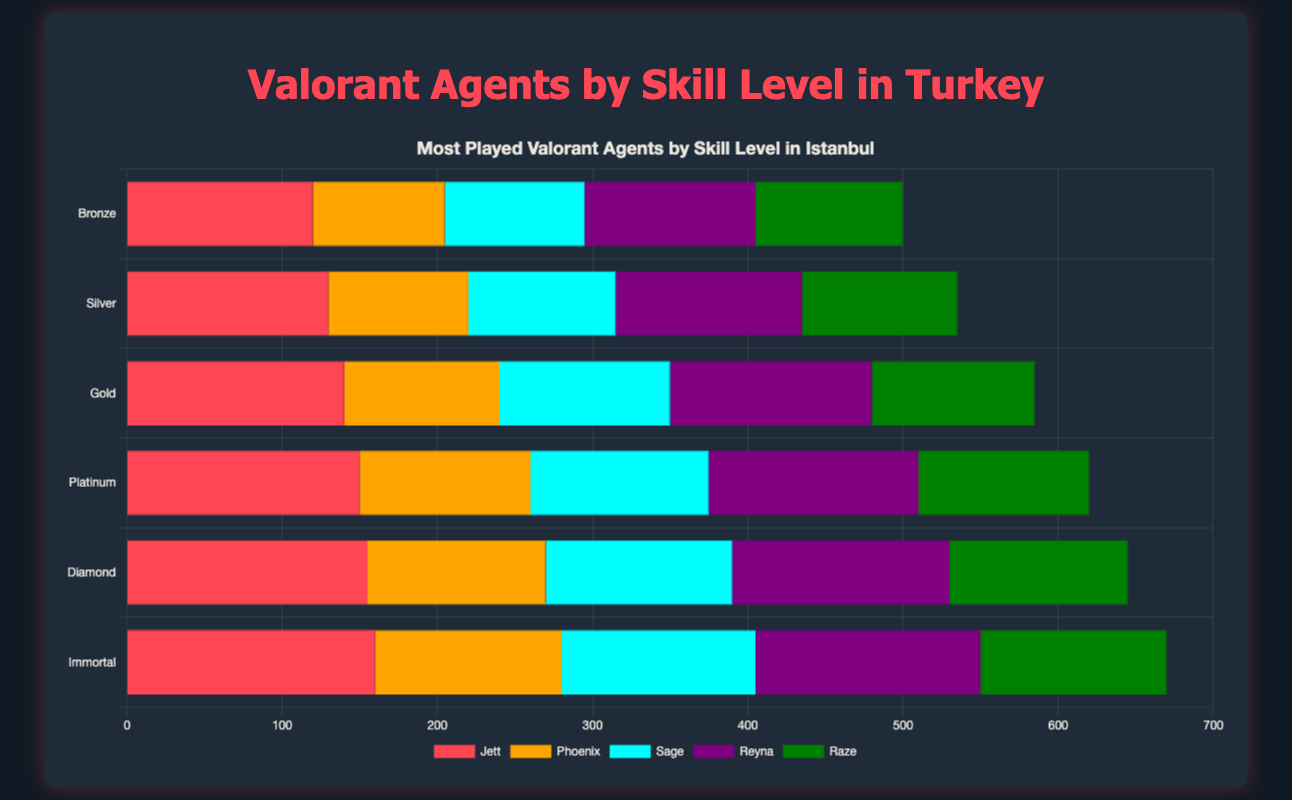Which agent is the most played in Immortal skill level in Istanbul? The chart shows the number of times each agent is played across different skill levels in Istanbul. For Immortal players, the heights of the bars representing Jett, Phoenix, Sage, Reyna, and Raze should be compared. Jett has the highest bar.
Answer: Jett Which agent has the least played occurrences in the Bronze skill level in Ankara? To determine the least played agent in Bronze skill level in Ankara, examine the heights of the bars for Jett, Phoenix, Sage, Reyna, and Raze. Phoenix has the shortest bar.
Answer: Phoenix What is the total number of times Jett is played across all skill levels in Izmir? Sum the heights of the bars representing Jett across all the skill levels in Izmir. Those values are 115 (Bronze) + 125 (Silver) + 135 (Gold) + 145 (Platinum) + 150 (Diamond) + 155 (Immortal). Therefore, the total is 115 + 125 + 135 + 145 + 150 + 155 = 825.
Answer: 825 Which agent sees the largest increase in play from Bronze to Immortal skill level in Bursa? Find the differences in bars' heights between the Immortal and Bronze levels for each agent in Bursa. For each agent: Jett (153 - 112 = 41), Phoenix (117 - 82 = 35), Sage (121 - 86 = 35), Reyna (134 - 104 = 30), and Raze (116 - 91 = 25). Jett has the largest increase.
Answer: Jett In Antalya, which skill level plays Phoenix more times than Reyna? Compare the heights of the bars representing Phoenix and Reyna at each skill level in Antalya. Phoenix is played more than Reyna at Bronze and Diamond levels.
Answer: Bronze, Diamond Across all skill levels in Istanbul, what is the average number of times Sage is played? Calculate the average by summing the heights of the Sage bars for all skill levels in Istanbul and dividing by the number of skill levels: (90 + 95 + 110 + 115 + 120 + 125) / 6 = 655 / 6 ≈ 109.17.
Answer: ~109.17 Who is more popular in Diamond skill level, Jett or Raze, in all regions? Compare the heights of the bars for Jett and Raze at the Diamond level for Istanbul, Ankara, Izmir, Bursa, and Antalya. Jett: (155 + 145 + 150 + 148 + 149), Raze: (115 + 110 + 113 + 111 + 114). Jett's values sum to 747, and Raze's sum to 563.
Answer: Jett In which skill level in Istanbul does Raze see the highest number of plays? Look for the highest bar representing Raze in each skill level in Istanbul. Immortal has the highest bar for Raze at 120 plays.
Answer: Immortal By how many times does Reyna's play count increase from Bronze to Diamond in Ankara? Subtract the Bronze level plays from the Diamond level plays for Reyna in Ankara. Reyna's Diamond play count is 130, and Bronze is 105, so 130 - 105 = 25.
Answer: 25 